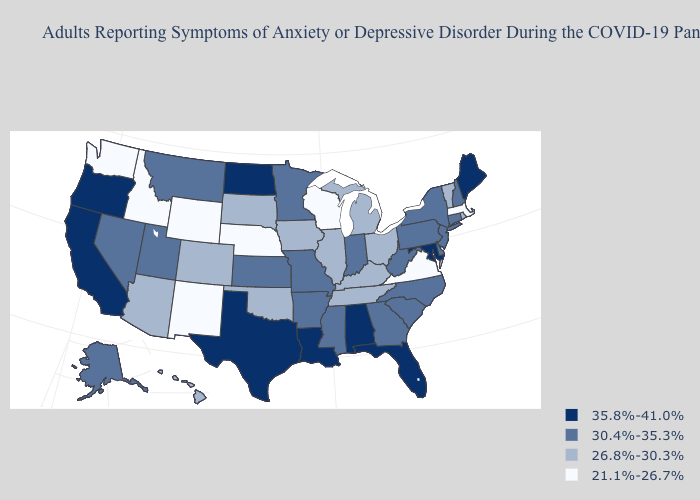Name the states that have a value in the range 26.8%-30.3%?
Write a very short answer. Arizona, Colorado, Hawaii, Illinois, Iowa, Kentucky, Michigan, Ohio, Oklahoma, Rhode Island, South Dakota, Tennessee, Vermont. Among the states that border Georgia , which have the lowest value?
Concise answer only. Tennessee. What is the highest value in the South ?
Give a very brief answer. 35.8%-41.0%. Which states have the lowest value in the South?
Answer briefly. Virginia. Does Maryland have the same value as Delaware?
Give a very brief answer. No. What is the value of North Carolina?
Write a very short answer. 30.4%-35.3%. What is the value of Kansas?
Be succinct. 30.4%-35.3%. What is the value of Mississippi?
Quick response, please. 30.4%-35.3%. Name the states that have a value in the range 26.8%-30.3%?
Be succinct. Arizona, Colorado, Hawaii, Illinois, Iowa, Kentucky, Michigan, Ohio, Oklahoma, Rhode Island, South Dakota, Tennessee, Vermont. Name the states that have a value in the range 35.8%-41.0%?
Short answer required. Alabama, California, Florida, Louisiana, Maine, Maryland, North Dakota, Oregon, Texas. Among the states that border North Dakota , does Montana have the lowest value?
Concise answer only. No. How many symbols are there in the legend?
Give a very brief answer. 4. What is the value of Rhode Island?
Answer briefly. 26.8%-30.3%. Which states have the lowest value in the USA?
Write a very short answer. Idaho, Massachusetts, Nebraska, New Mexico, Virginia, Washington, Wisconsin, Wyoming. What is the value of Iowa?
Quick response, please. 26.8%-30.3%. 